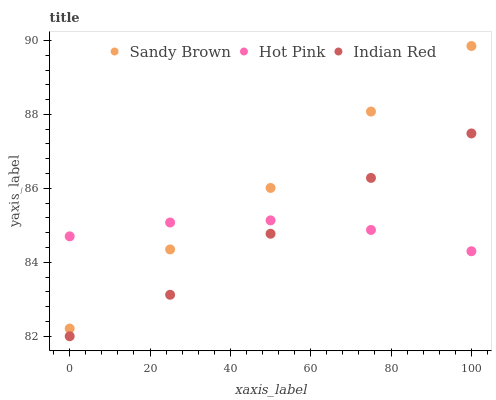Does Indian Red have the minimum area under the curve?
Answer yes or no. Yes. Does Sandy Brown have the maximum area under the curve?
Answer yes or no. Yes. Does Sandy Brown have the minimum area under the curve?
Answer yes or no. No. Does Indian Red have the maximum area under the curve?
Answer yes or no. No. Is Hot Pink the smoothest?
Answer yes or no. Yes. Is Sandy Brown the roughest?
Answer yes or no. Yes. Is Indian Red the smoothest?
Answer yes or no. No. Is Indian Red the roughest?
Answer yes or no. No. Does Indian Red have the lowest value?
Answer yes or no. Yes. Does Sandy Brown have the lowest value?
Answer yes or no. No. Does Sandy Brown have the highest value?
Answer yes or no. Yes. Does Indian Red have the highest value?
Answer yes or no. No. Is Indian Red less than Sandy Brown?
Answer yes or no. Yes. Is Sandy Brown greater than Indian Red?
Answer yes or no. Yes. Does Hot Pink intersect Sandy Brown?
Answer yes or no. Yes. Is Hot Pink less than Sandy Brown?
Answer yes or no. No. Is Hot Pink greater than Sandy Brown?
Answer yes or no. No. Does Indian Red intersect Sandy Brown?
Answer yes or no. No. 